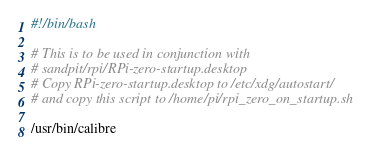Convert code to text. <code><loc_0><loc_0><loc_500><loc_500><_Bash_>#!/bin/bash

# This is to be used in conjunction with 
# sandpit/rpi/RPi-zero-startup.desktop
# Copy RPi-zero-startup.desktop to /etc/xdg/autostart/
# and copy this script to /home/pi/rpi_zero_on_startup.sh

/usr/bin/calibre

</code> 